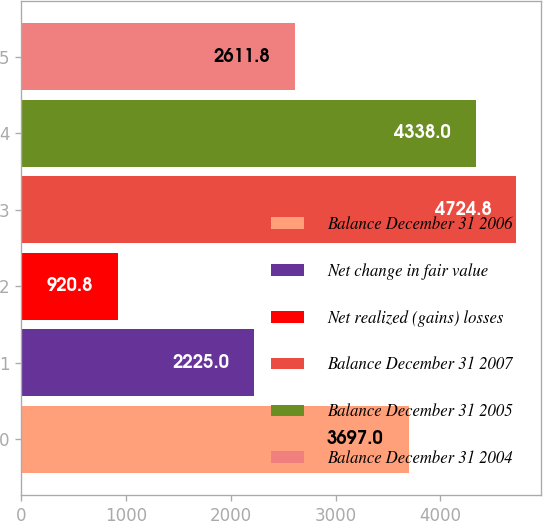Convert chart. <chart><loc_0><loc_0><loc_500><loc_500><bar_chart><fcel>Balance December 31 2006<fcel>Net change in fair value<fcel>Net realized (gains) losses<fcel>Balance December 31 2007<fcel>Balance December 31 2005<fcel>Balance December 31 2004<nl><fcel>3697<fcel>2225<fcel>920.8<fcel>4724.8<fcel>4338<fcel>2611.8<nl></chart> 